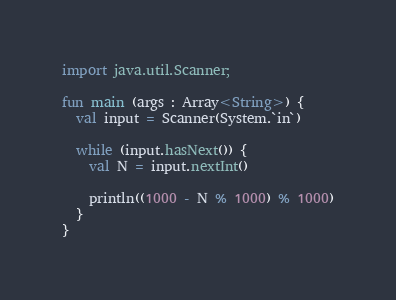<code> <loc_0><loc_0><loc_500><loc_500><_Kotlin_>import java.util.Scanner;

fun main (args : Array<String>) {
  val input = Scanner(System.`in`)
  
  while (input.hasNext()) {
    val N = input.nextInt()
    
    println((1000 - N % 1000) % 1000)
  }
}</code> 